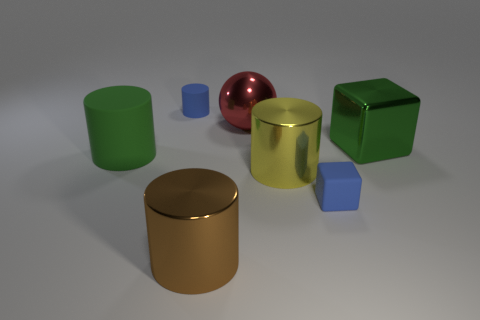Subtract all big matte cylinders. How many cylinders are left? 3 Subtract all blue cylinders. How many cylinders are left? 3 Subtract all green cylinders. Subtract all blue blocks. How many cylinders are left? 3 Add 1 gray objects. How many objects exist? 8 Subtract all cylinders. How many objects are left? 3 Subtract 1 blue blocks. How many objects are left? 6 Subtract all tiny green matte cylinders. Subtract all big metallic objects. How many objects are left? 3 Add 3 big metal blocks. How many big metal blocks are left? 4 Add 7 balls. How many balls exist? 8 